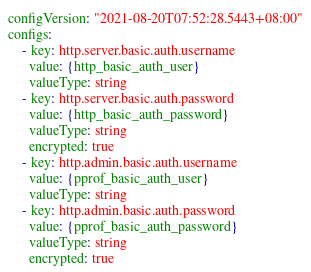Convert code to text. <code><loc_0><loc_0><loc_500><loc_500><_YAML_>configVersion: "2021-08-20T07:52:28.5443+08:00"
configs:
    - key: http.server.basic.auth.username
      value: {http_basic_auth_user}
      valueType: string
    - key: http.server.basic.auth.password
      value: {http_basic_auth_password}
      valueType: string
      encrypted: true
    - key: http.admin.basic.auth.username
      value: {pprof_basic_auth_user}
      valueType: string
    - key: http.admin.basic.auth.password
      value: {pprof_basic_auth_password}
      valueType: string
      encrypted: true
</code> 